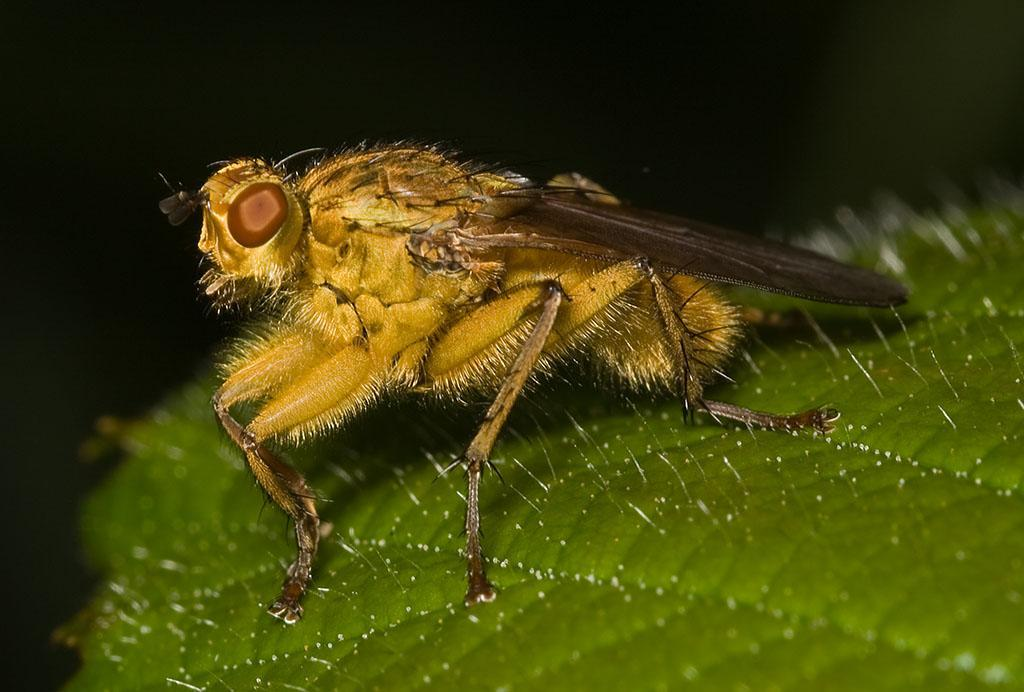What is the main subject of the image? There is an insect in the image. Where is the insect located? The insect is on a leaf. What can be observed about the background of the image? The background of the image is dark. What type of blade is being used to start the crate in the image? There is no blade or crate present in the image; it features an insect on a leaf with a dark background. 